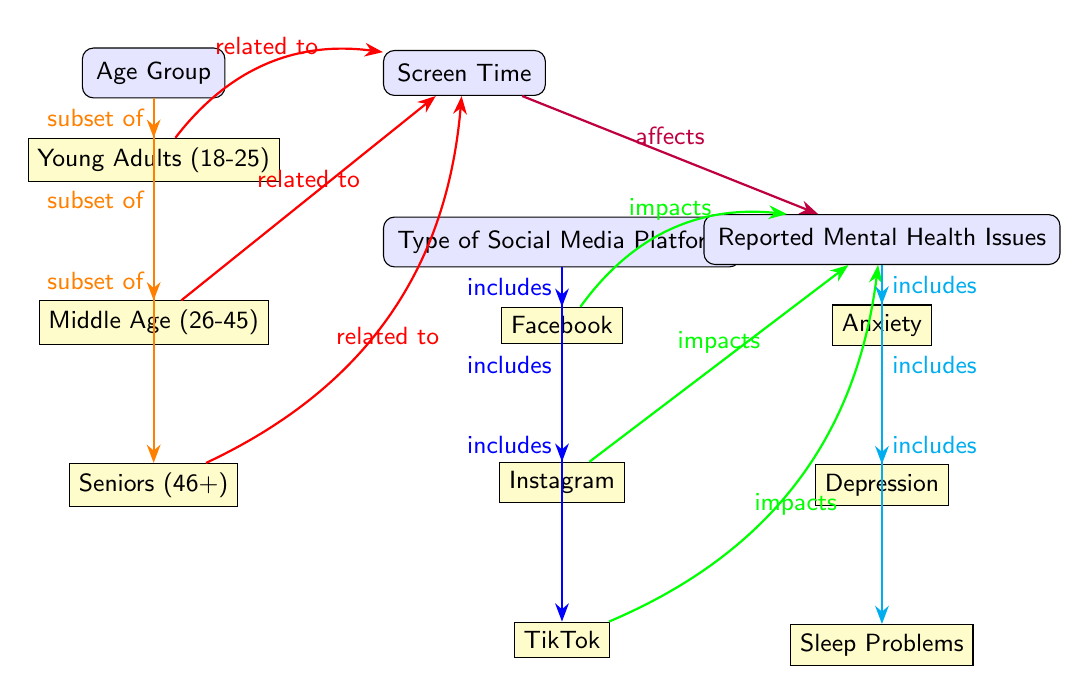What are the age groups represented in the diagram? The diagram shows three age groups: Young Adults (18-25), Middle Age (26-45), and Seniors (46+).
Answer: Young Adults, Middle Age, Seniors Which factors are linked to mental health issues in the diagram? The diagram shows the factors of Screen Time and Type of Social Media Platform that affect mental health issues. Screen Time is directly affecting the reported mental health issues, and several social media platforms, including Facebook, Instagram, and TikTok, are included as factors impacting mental health.
Answer: Screen Time, Type of Social Media Platform What is one mental health issue that is included in the diagram? The diagram lists three mental health issues: Anxiety, Depression, and Sleep Problems. Any of these could be an answer, but one is specifically requested.
Answer: Anxiety How many types of social media platforms are included in the diagram? There are three types of social media platforms included: Facebook, Instagram, and TikTok. The count can be determined by looking at the subnodes under the "Type of Social Media Platform" group.
Answer: Three How does screen time relate to age groups in the diagram? The diagram shows a relationship where all age groups (young adults, middle age, and seniors) are related to screen time, with arrows indicating this relationship. Young adults and seniors have a bend indicating a more specific relationship, showing varied impacts across age groups.
Answer: Related to all age groups Which social media platform is indicated to impact the mental health of young adults? The diagram shows an arrow from TikTok indicating that it impacts the mental health issues specifically related to young adults, as indicated by the bend in the arrow pointing from young adults towards TikTok.
Answer: TikTok What type of relationship exists between screen time and reported mental health issues? The diagram illustrates a direct relationship where an arrow from Screen Time affects Reported Mental Health Issues, suggesting that increased or specific patterns of screen time directly influence the mental health outcomes.
Answer: Affects How many mental health issues are listed under the 'Reported Mental Health Issues' category? The diagram indicates that there are three mental health issues listed under the "Reported Mental Health Issues" node: Anxiety, Depression, and Sleep Problems. This can be confirmed by counting the subnodes that branch from it.
Answer: Three What is the nature of the connection between Instagram and mental health issues according to the diagram? The diagram shows a direct impact connection with a clear arrow from Instagram to Reported Mental Health Issues. This indicates that Instagram is linked to potential issues in mental health directly.
Answer: Impacts 